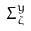Convert formula to latex. <formula><loc_0><loc_0><loc_500><loc_500>\Sigma _ { \zeta } ^ { y }</formula> 